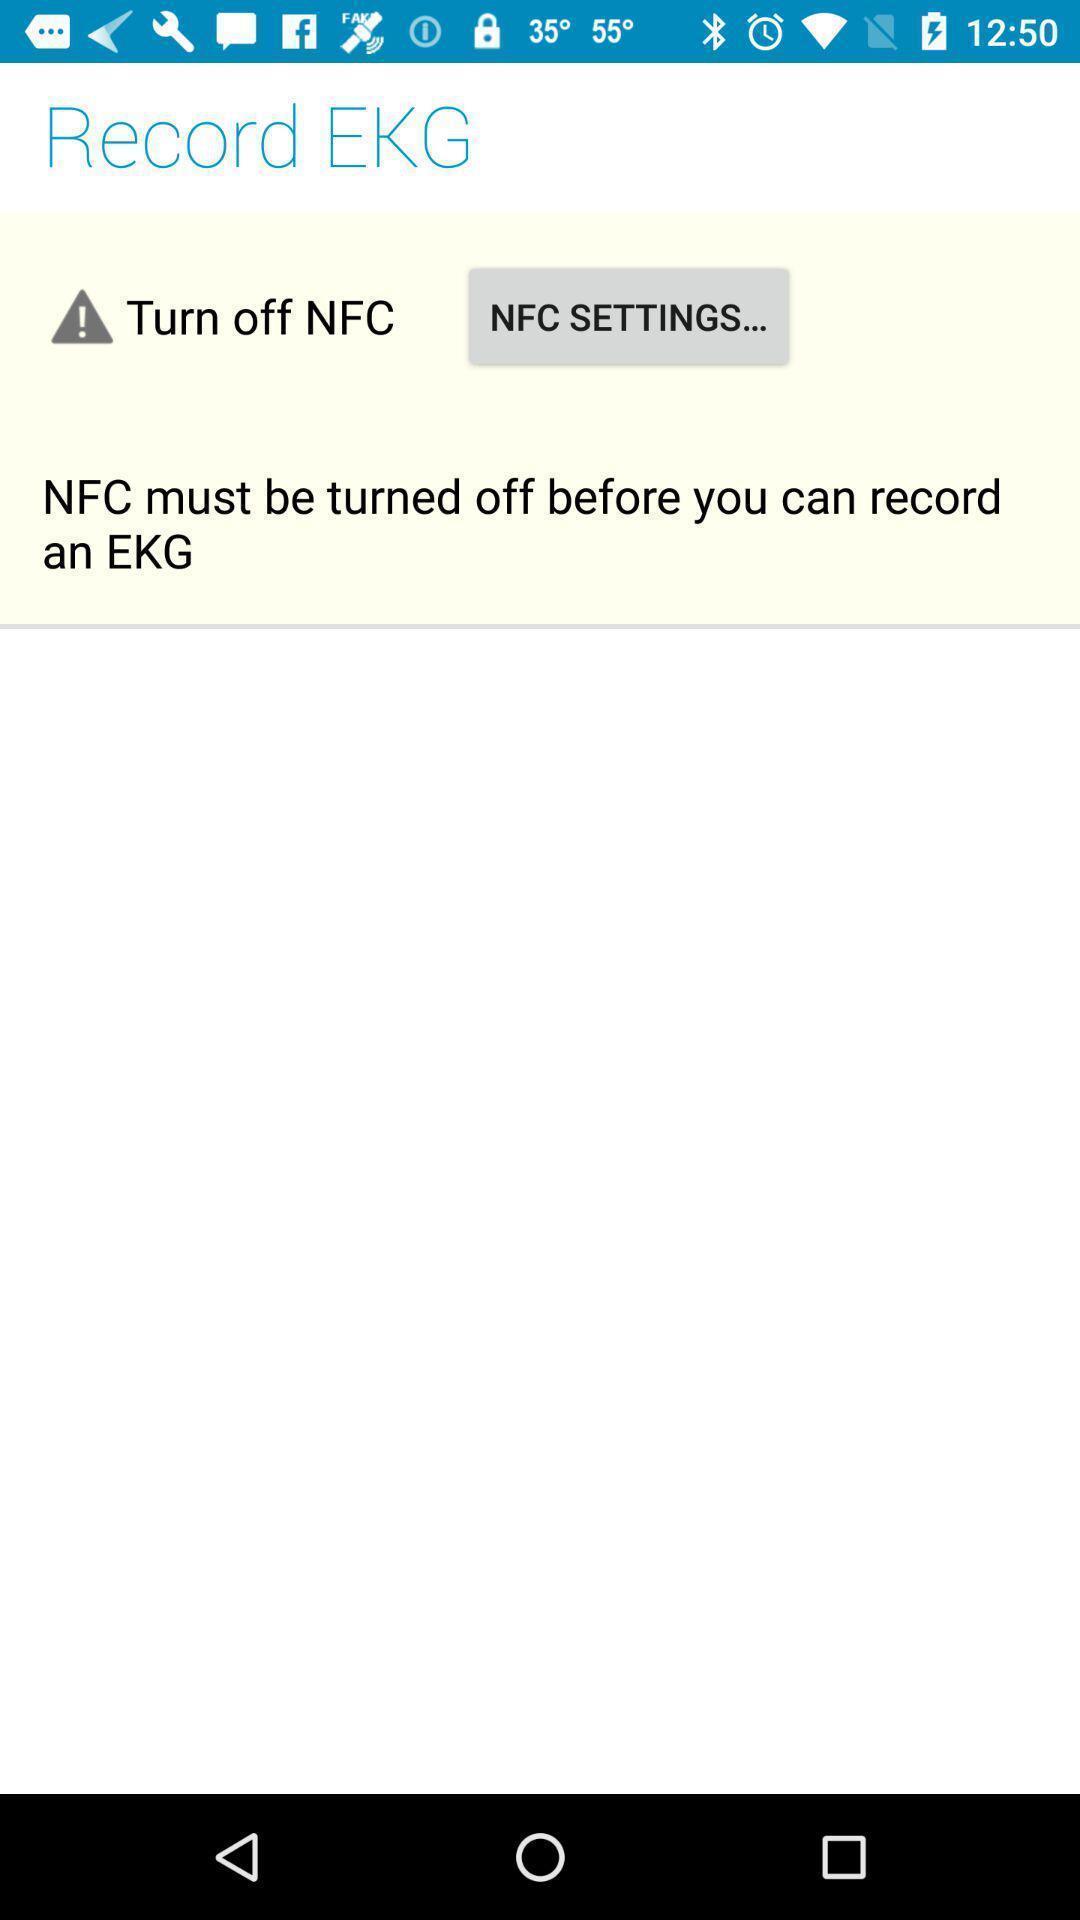Please provide a description for this image. Page showing for recording ekg. 